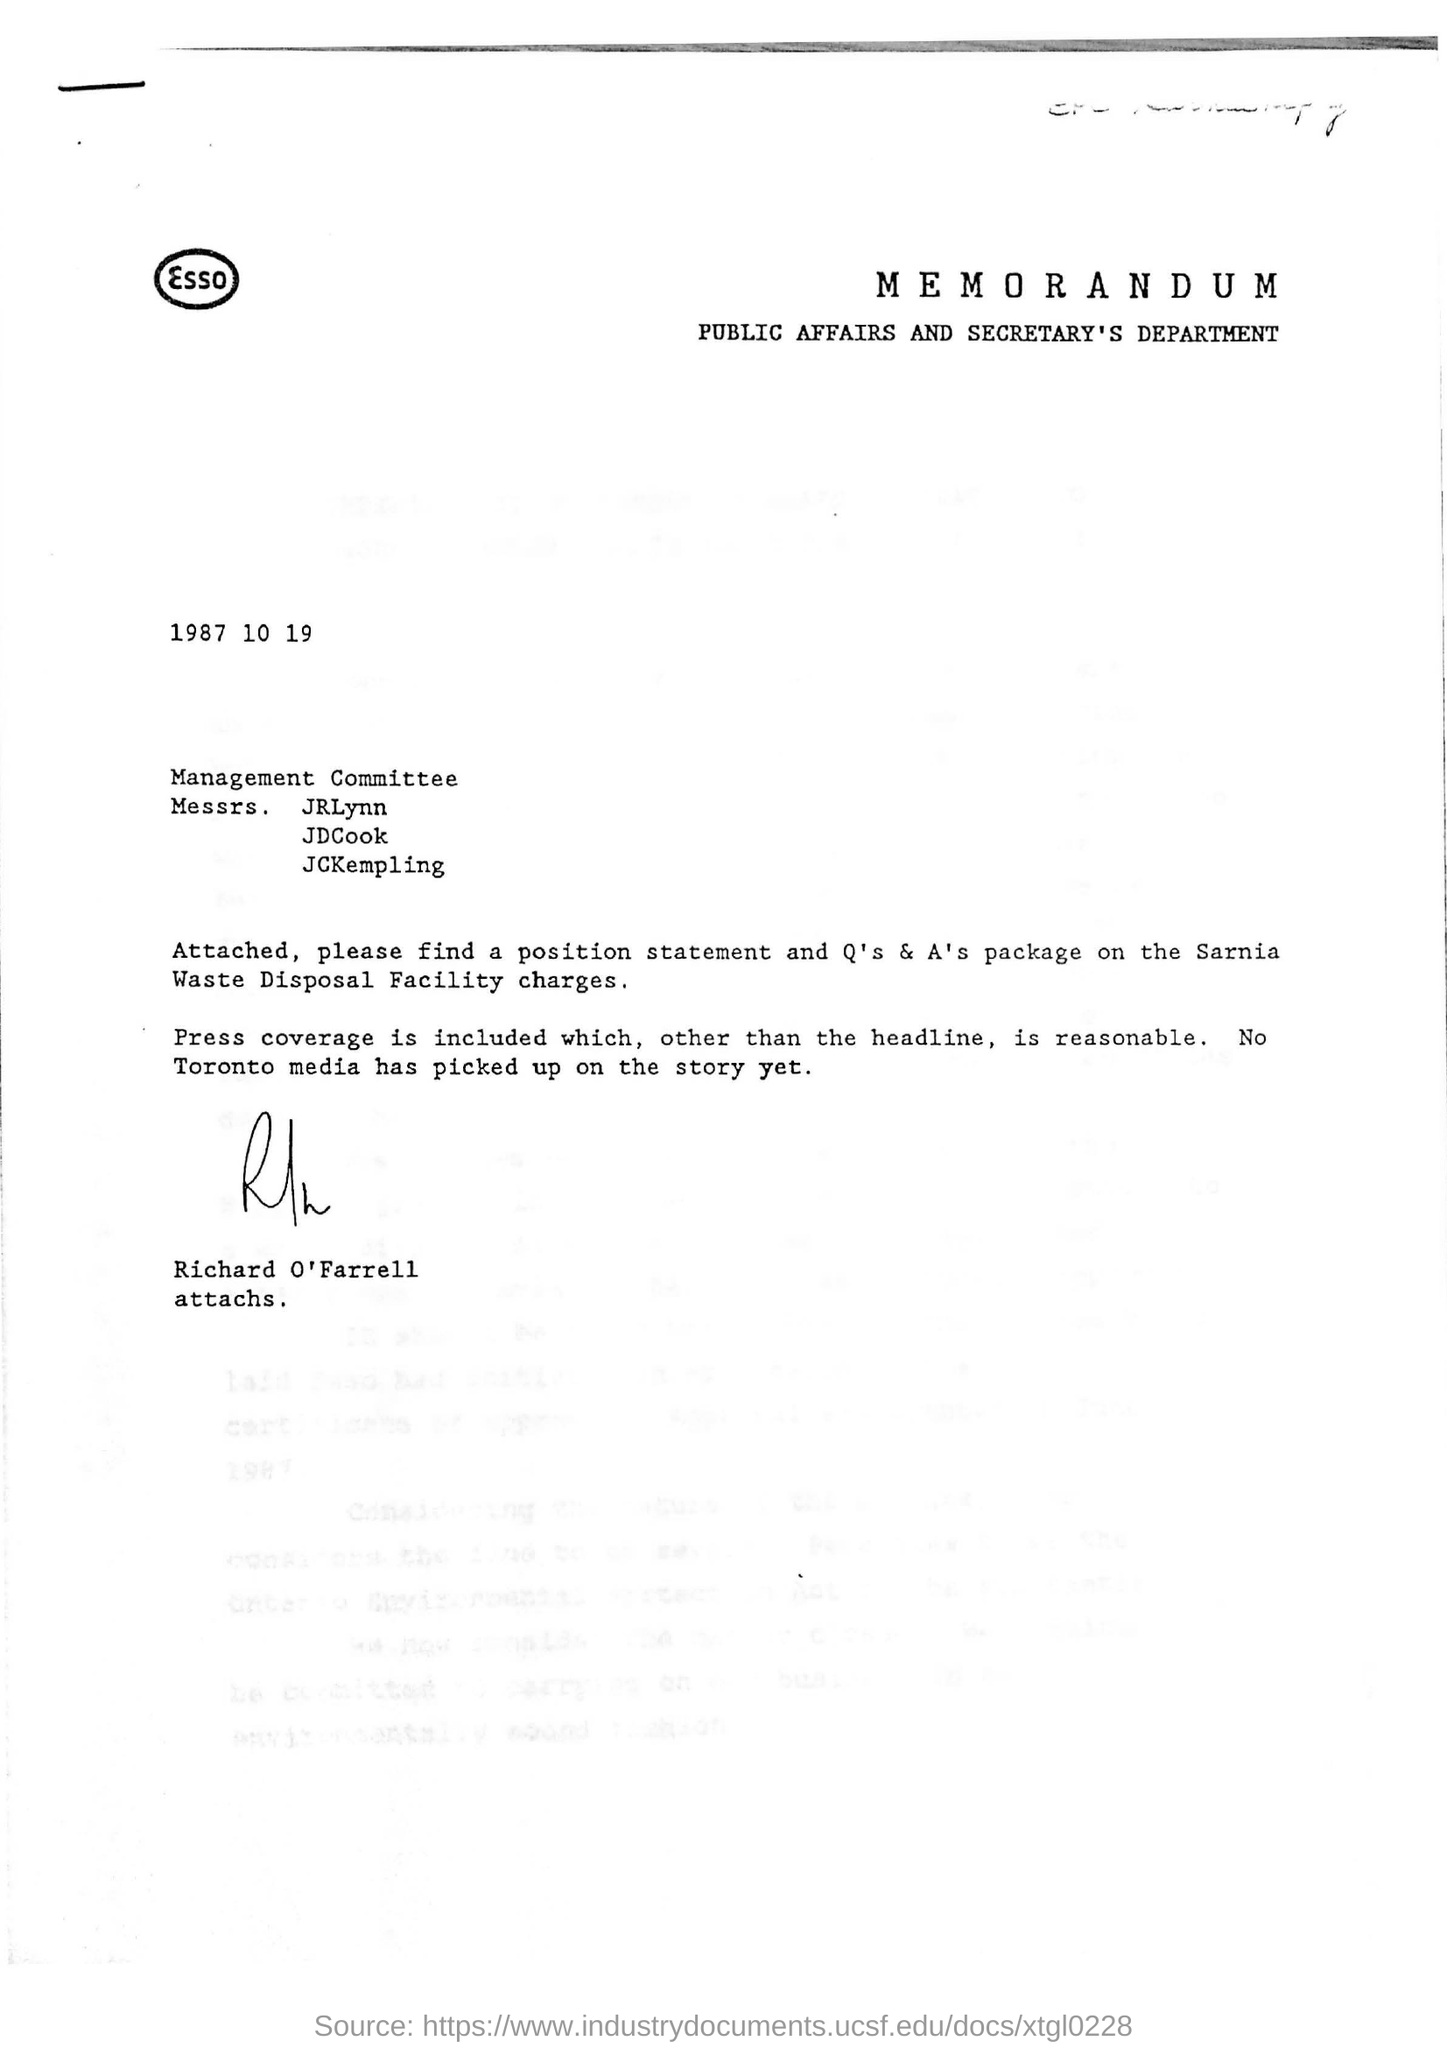Highlight a few significant elements in this photo. The Public Affairs and Secretary's Department is mentioned. 